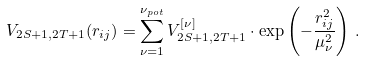<formula> <loc_0><loc_0><loc_500><loc_500>V _ { 2 S + 1 , 2 T + 1 } ( r _ { i j } ) = \sum _ { \nu = 1 } ^ { \nu _ { p o t } } V _ { 2 S + 1 , 2 T + 1 } ^ { [ \nu ] } \cdot \exp \left ( - \frac { r _ { i j } ^ { 2 } } { \mu _ { \nu } ^ { 2 } } \right ) \, .</formula> 